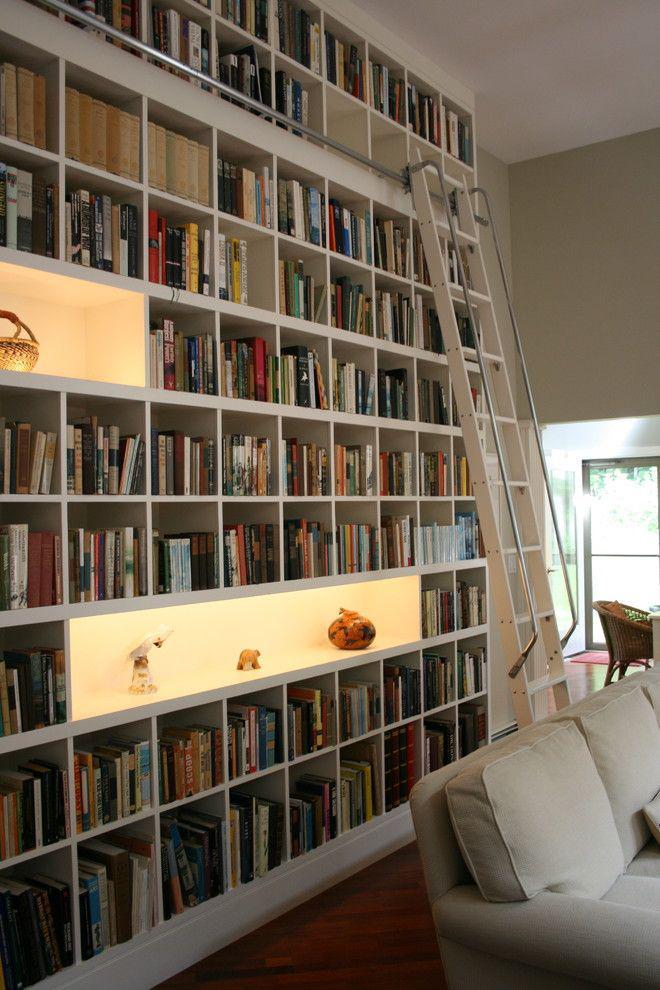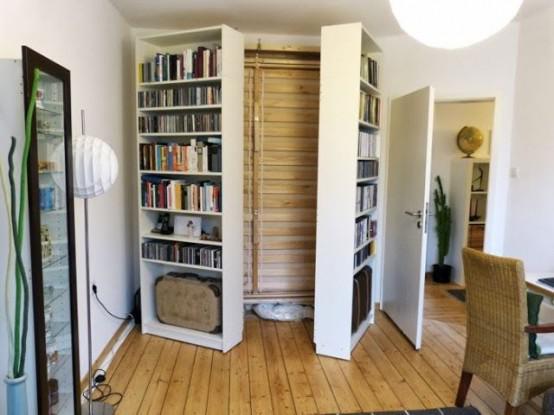The first image is the image on the left, the second image is the image on the right. For the images shown, is this caption "The bookshelves in both pictures are facing the left side of the picture." true? Answer yes or no. No. The first image is the image on the left, the second image is the image on the right. Evaluate the accuracy of this statement regarding the images: "a bookshelf is behind a small white table". Is it true? Answer yes or no. No. 